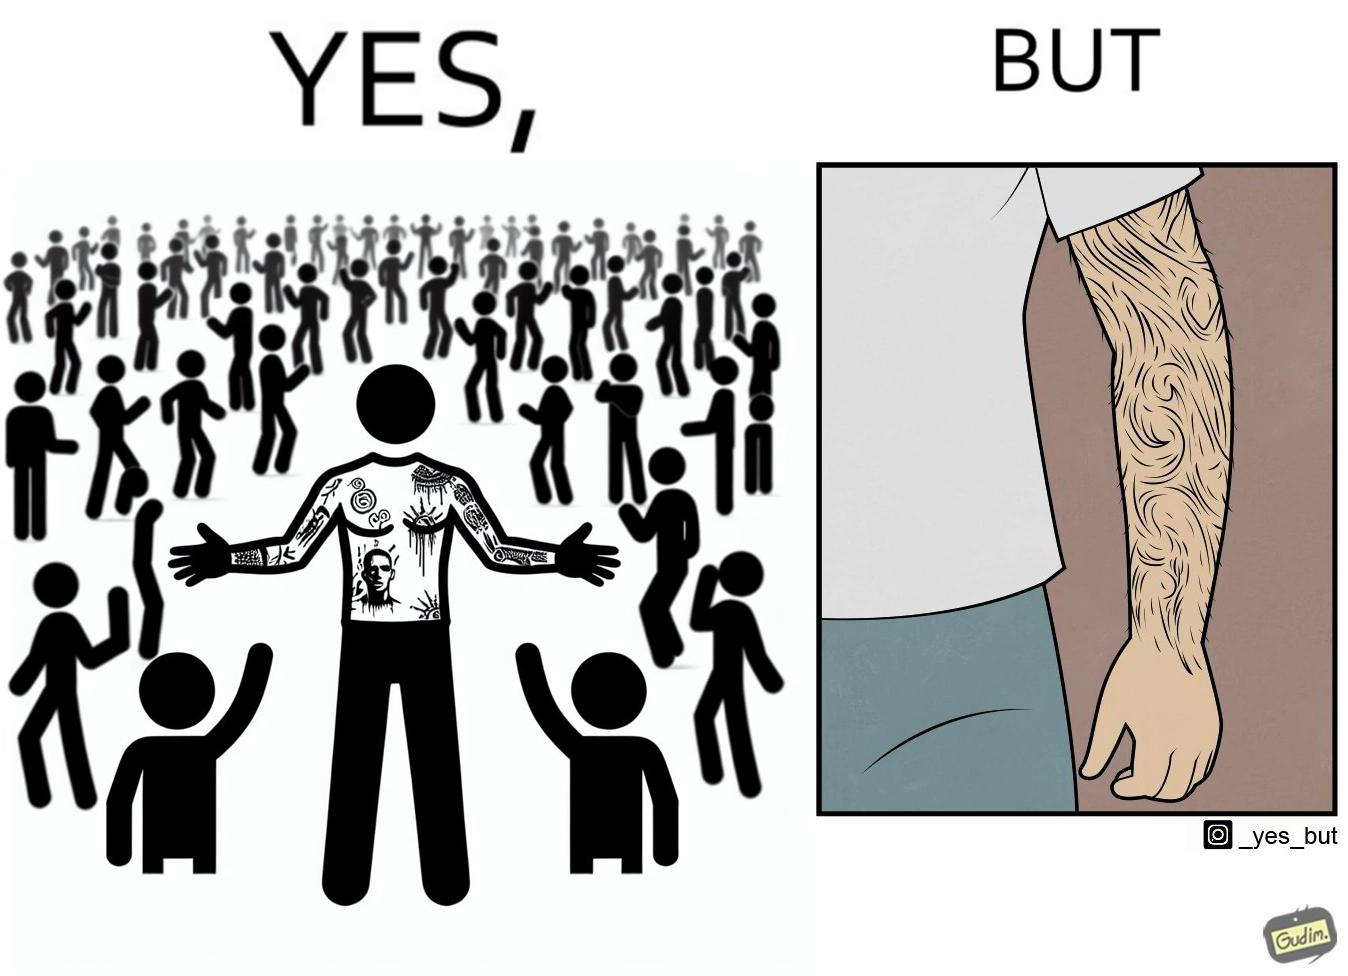Compare the left and right sides of this image. In the left part of the image: The image shows a man with tattoos on both of his arms. He is wearing white T-shirt . In the right part of the image: The image shows a closeup of an arm. The arm is shown to be very hairy and the hairs are wavy. 